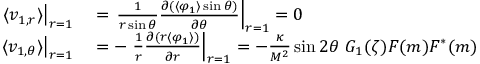<formula> <loc_0><loc_0><loc_500><loc_500>\begin{array} { r l } { \langle v _ { 1 , r } \rangle \right | _ { r = 1 } } & = \frac { 1 } { r \sin \theta } \frac { \partial ( \langle \varphi _ { 1 } \rangle \sin \theta ) } { \partial \theta } \right | _ { r = 1 } = 0 } \\ { \langle v _ { 1 , \theta } \rangle \right | _ { r = 1 } } & = - \frac { 1 } { r } \frac { \partial ( r \langle \varphi _ { 1 } \rangle ) } { \partial r } \right | _ { r = 1 } = - \frac { \kappa } { M ^ { 2 } } \sin 2 \theta G _ { 1 } ( \zeta ) F ( m ) F ^ { * } ( m ) } \end{array}</formula> 